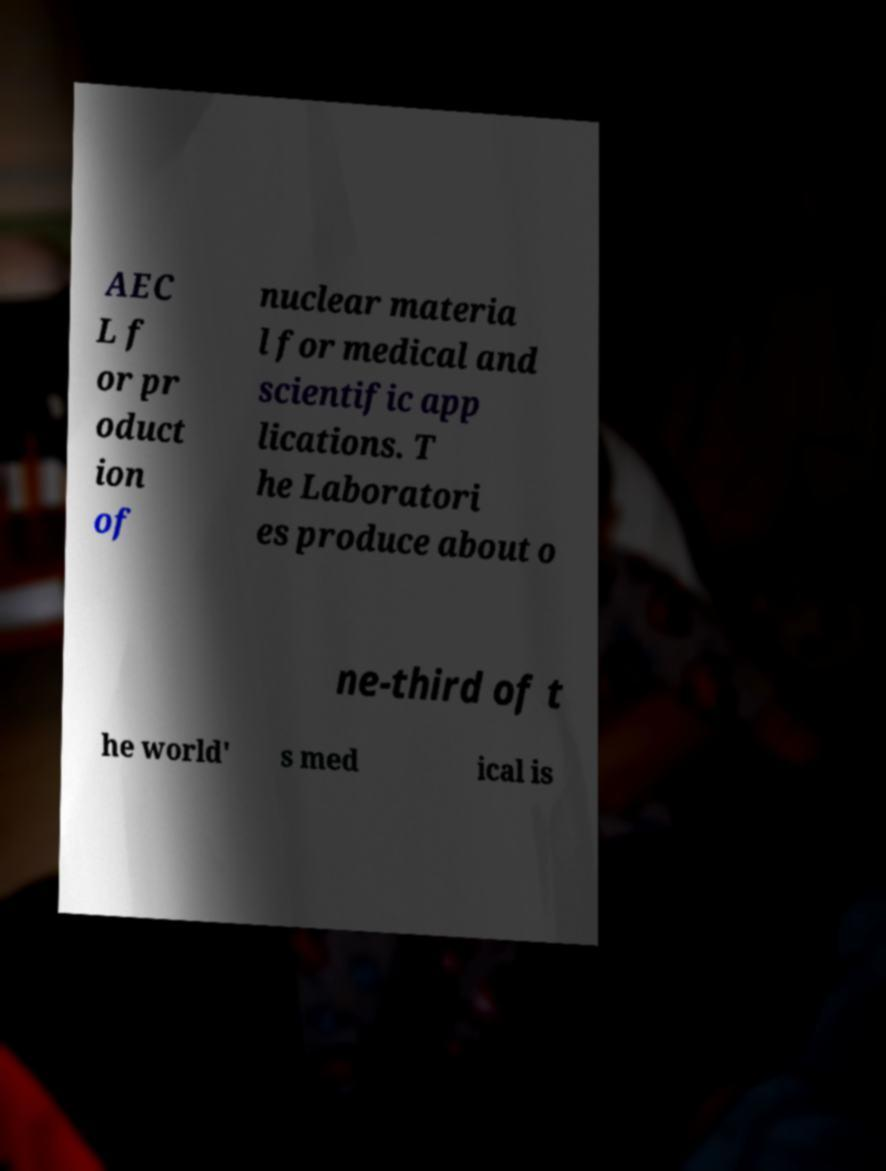There's text embedded in this image that I need extracted. Can you transcribe it verbatim? AEC L f or pr oduct ion of nuclear materia l for medical and scientific app lications. T he Laboratori es produce about o ne-third of t he world' s med ical is 